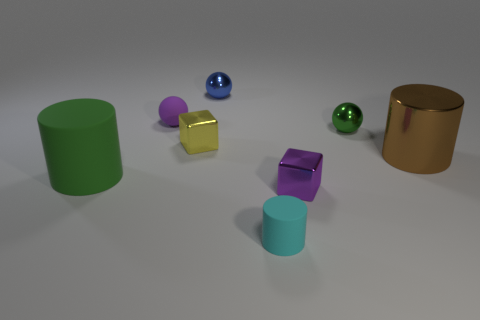Are there an equal number of balls in front of the purple block and purple matte objects that are to the left of the blue metallic sphere?
Provide a succinct answer. No. What number of tiny cyan matte objects have the same shape as the small blue object?
Ensure brevity in your answer.  0. Are there any cylinders that have the same material as the big green thing?
Your answer should be compact. Yes. There is a tiny metallic object that is the same color as the small matte ball; what is its shape?
Offer a very short reply. Cube. How many small yellow cubes are there?
Give a very brief answer. 1. How many spheres are either large gray matte things or brown things?
Keep it short and to the point. 0. What color is the matte cylinder that is the same size as the brown thing?
Offer a very short reply. Green. What number of green objects are on the right side of the large green rubber cylinder and to the left of the small green object?
Your answer should be compact. 0. What material is the yellow object?
Offer a very short reply. Metal. How many objects are either cylinders or tiny purple metal objects?
Ensure brevity in your answer.  4. 